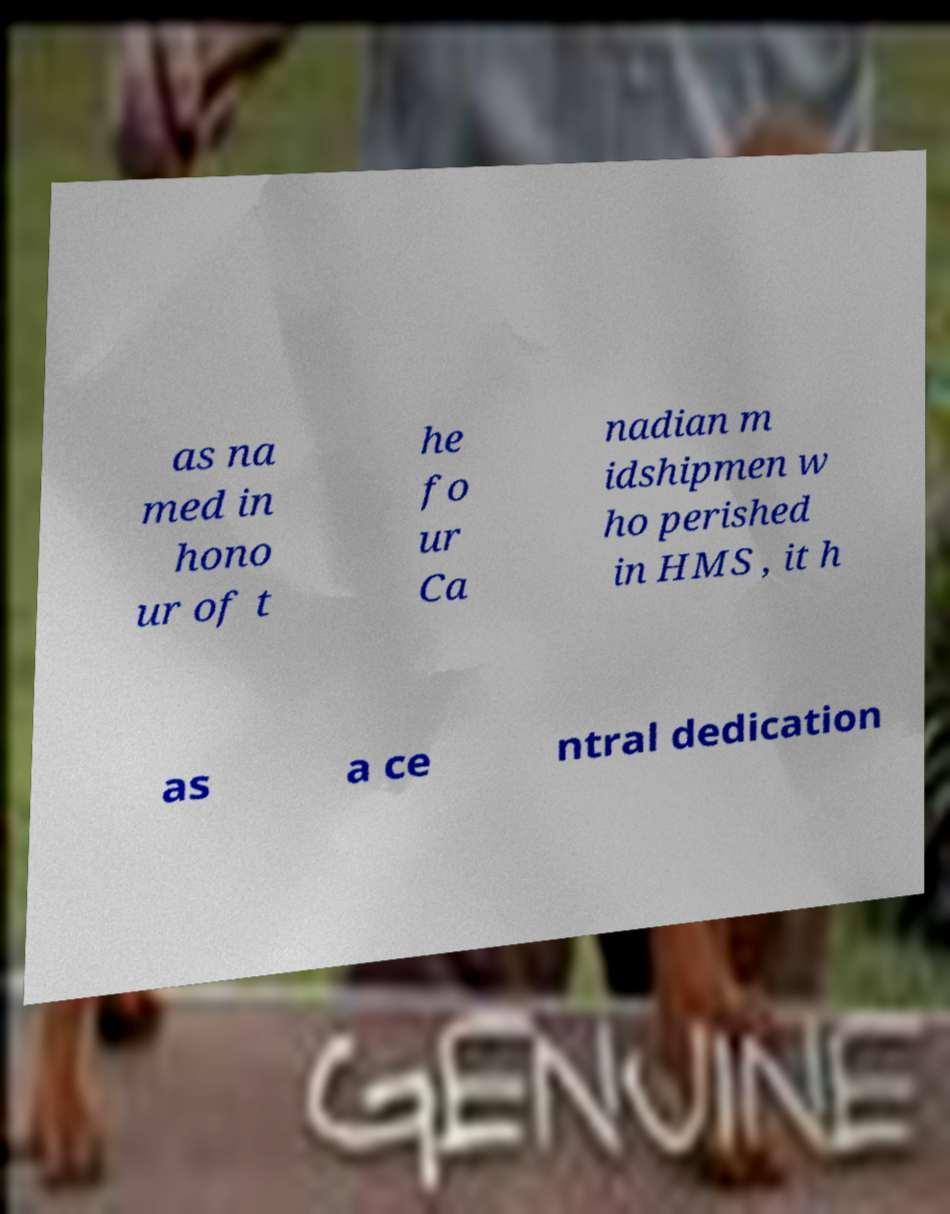There's text embedded in this image that I need extracted. Can you transcribe it verbatim? as na med in hono ur of t he fo ur Ca nadian m idshipmen w ho perished in HMS , it h as a ce ntral dedication 